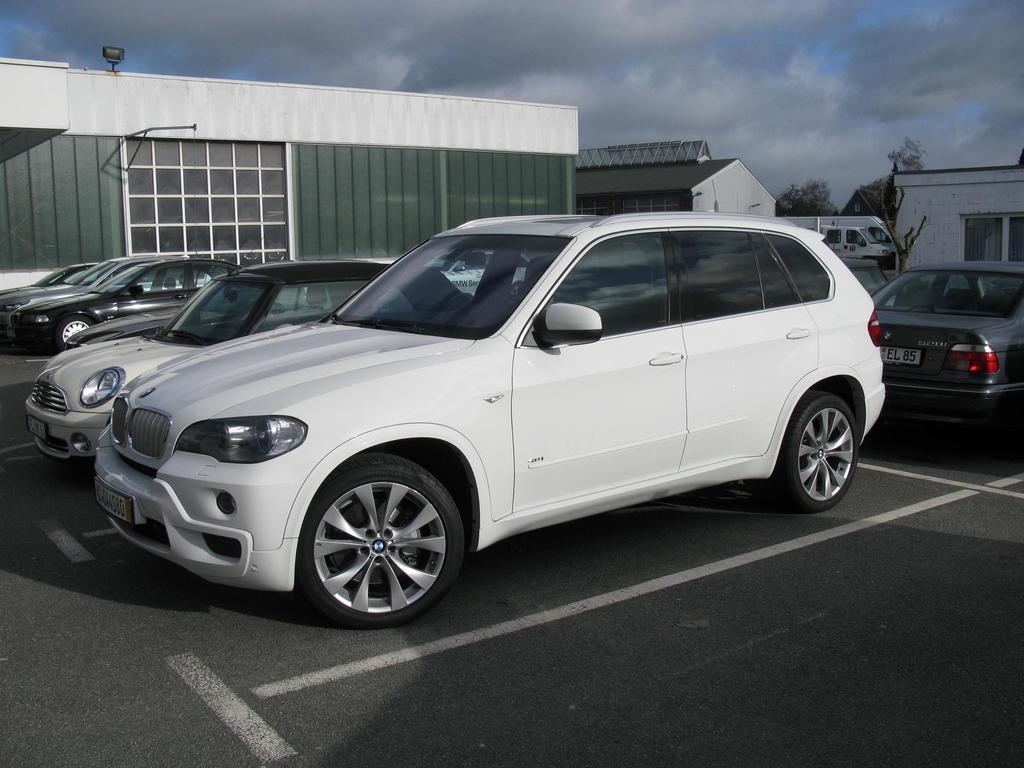Please provide a concise description of this image. In this image I can see there are many cars parked on the ground and at back there are some houses and in the background there is the sky 